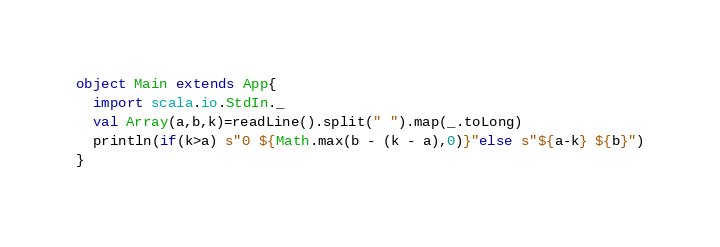<code> <loc_0><loc_0><loc_500><loc_500><_Scala_>object Main extends App{
  import scala.io.StdIn._
  val Array(a,b,k)=readLine().split(" ").map(_.toLong)
  println(if(k>a) s"0 ${Math.max(b - (k - a),0)}"else s"${a-k} ${b}")
}</code> 